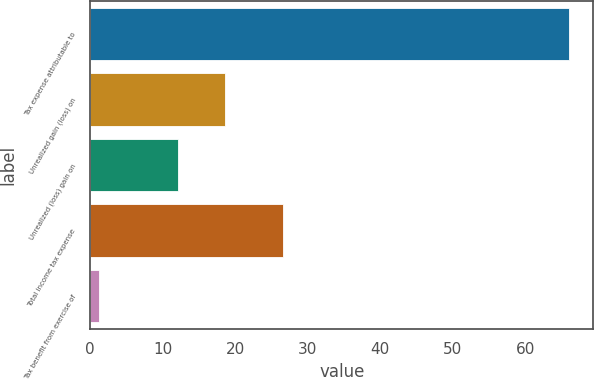Convert chart to OTSL. <chart><loc_0><loc_0><loc_500><loc_500><bar_chart><fcel>Tax expense attributable to<fcel>Unrealized gain (loss) on<fcel>Unrealized (loss) gain on<fcel>Total income tax expense<fcel>Tax benefit from exercise of<nl><fcel>66.1<fcel>18.59<fcel>12.1<fcel>26.6<fcel>1.2<nl></chart> 